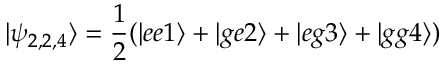Convert formula to latex. <formula><loc_0><loc_0><loc_500><loc_500>| \psi _ { 2 , 2 , 4 } \rangle = \frac { 1 } { 2 } ( | e e 1 \rangle + | g e 2 \rangle + | e g 3 \rangle + | g g 4 \rangle )</formula> 